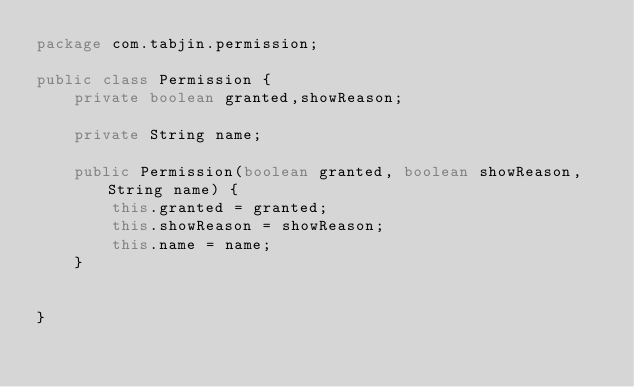Convert code to text. <code><loc_0><loc_0><loc_500><loc_500><_Java_>package com.tabjin.permission;

public class Permission {
    private boolean granted,showReason;

    private String name;

    public Permission(boolean granted, boolean showReason, String name) {
        this.granted = granted;
        this.showReason = showReason;
        this.name = name;
    }


}
</code> 